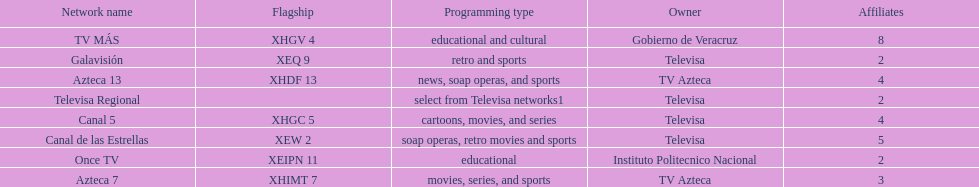How many networks show soap operas? 2. 